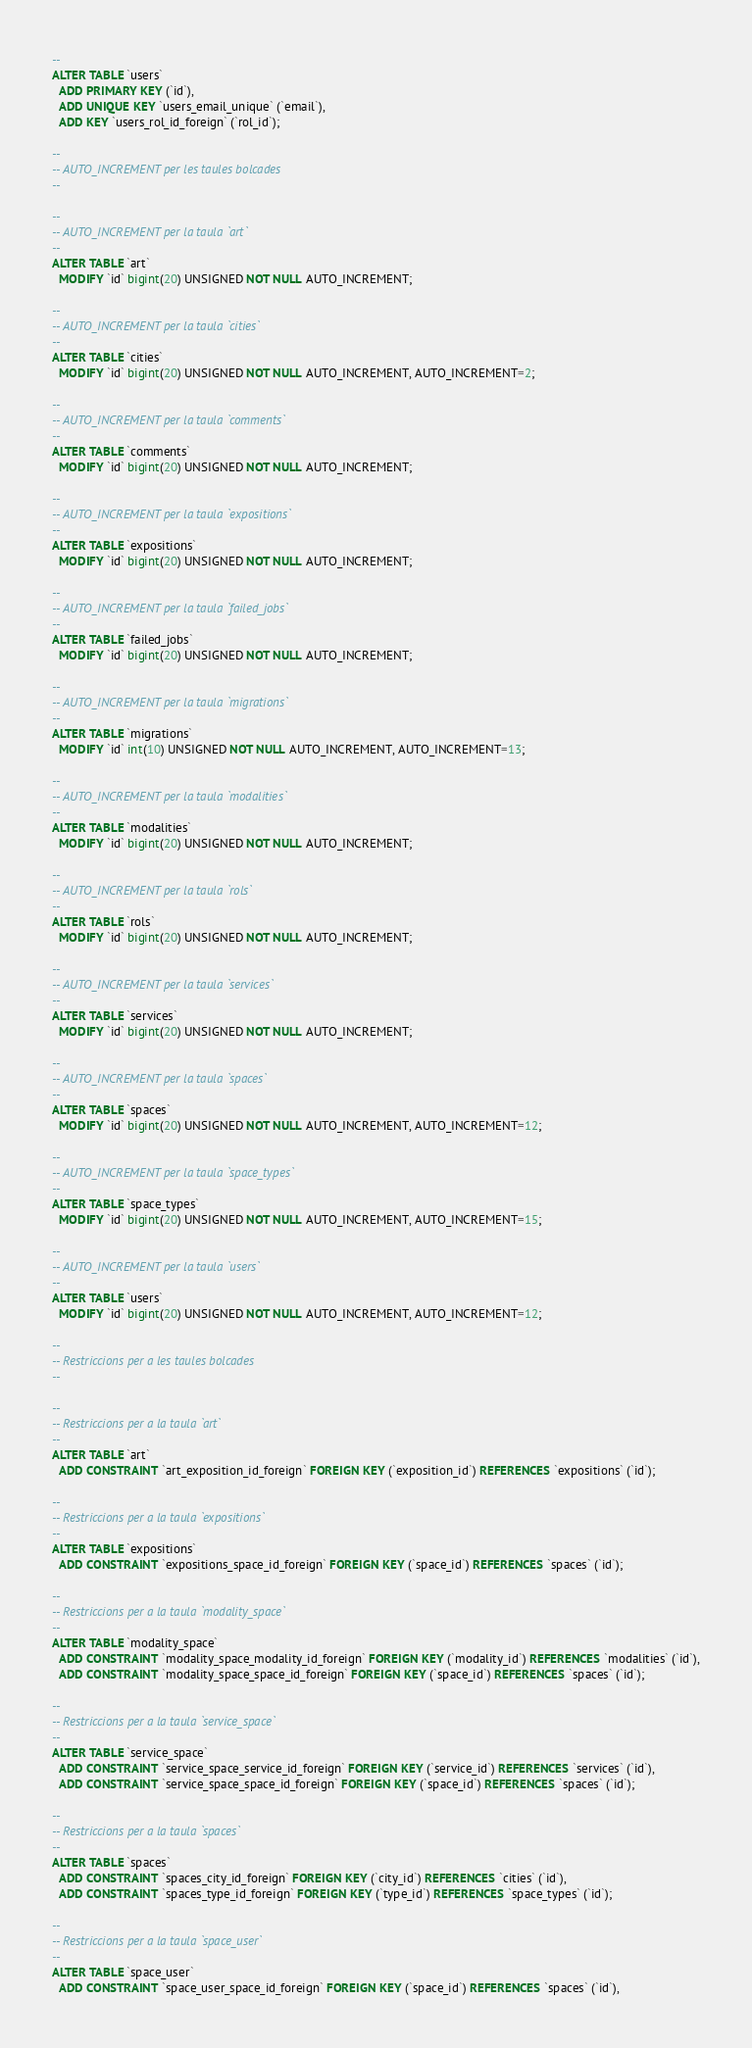Convert code to text. <code><loc_0><loc_0><loc_500><loc_500><_SQL_>--
ALTER TABLE `users`
  ADD PRIMARY KEY (`id`),
  ADD UNIQUE KEY `users_email_unique` (`email`),
  ADD KEY `users_rol_id_foreign` (`rol_id`);

--
-- AUTO_INCREMENT per les taules bolcades
--

--
-- AUTO_INCREMENT per la taula `art`
--
ALTER TABLE `art`
  MODIFY `id` bigint(20) UNSIGNED NOT NULL AUTO_INCREMENT;

--
-- AUTO_INCREMENT per la taula `cities`
--
ALTER TABLE `cities`
  MODIFY `id` bigint(20) UNSIGNED NOT NULL AUTO_INCREMENT, AUTO_INCREMENT=2;

--
-- AUTO_INCREMENT per la taula `comments`
--
ALTER TABLE `comments`
  MODIFY `id` bigint(20) UNSIGNED NOT NULL AUTO_INCREMENT;

--
-- AUTO_INCREMENT per la taula `expositions`
--
ALTER TABLE `expositions`
  MODIFY `id` bigint(20) UNSIGNED NOT NULL AUTO_INCREMENT;

--
-- AUTO_INCREMENT per la taula `failed_jobs`
--
ALTER TABLE `failed_jobs`
  MODIFY `id` bigint(20) UNSIGNED NOT NULL AUTO_INCREMENT;

--
-- AUTO_INCREMENT per la taula `migrations`
--
ALTER TABLE `migrations`
  MODIFY `id` int(10) UNSIGNED NOT NULL AUTO_INCREMENT, AUTO_INCREMENT=13;

--
-- AUTO_INCREMENT per la taula `modalities`
--
ALTER TABLE `modalities`
  MODIFY `id` bigint(20) UNSIGNED NOT NULL AUTO_INCREMENT;

--
-- AUTO_INCREMENT per la taula `rols`
--
ALTER TABLE `rols`
  MODIFY `id` bigint(20) UNSIGNED NOT NULL AUTO_INCREMENT;

--
-- AUTO_INCREMENT per la taula `services`
--
ALTER TABLE `services`
  MODIFY `id` bigint(20) UNSIGNED NOT NULL AUTO_INCREMENT;

--
-- AUTO_INCREMENT per la taula `spaces`
--
ALTER TABLE `spaces`
  MODIFY `id` bigint(20) UNSIGNED NOT NULL AUTO_INCREMENT, AUTO_INCREMENT=12;

--
-- AUTO_INCREMENT per la taula `space_types`
--
ALTER TABLE `space_types`
  MODIFY `id` bigint(20) UNSIGNED NOT NULL AUTO_INCREMENT, AUTO_INCREMENT=15;

--
-- AUTO_INCREMENT per la taula `users`
--
ALTER TABLE `users`
  MODIFY `id` bigint(20) UNSIGNED NOT NULL AUTO_INCREMENT, AUTO_INCREMENT=12;

--
-- Restriccions per a les taules bolcades
--

--
-- Restriccions per a la taula `art`
--
ALTER TABLE `art`
  ADD CONSTRAINT `art_exposition_id_foreign` FOREIGN KEY (`exposition_id`) REFERENCES `expositions` (`id`);

--
-- Restriccions per a la taula `expositions`
--
ALTER TABLE `expositions`
  ADD CONSTRAINT `expositions_space_id_foreign` FOREIGN KEY (`space_id`) REFERENCES `spaces` (`id`);

--
-- Restriccions per a la taula `modality_space`
--
ALTER TABLE `modality_space`
  ADD CONSTRAINT `modality_space_modality_id_foreign` FOREIGN KEY (`modality_id`) REFERENCES `modalities` (`id`),
  ADD CONSTRAINT `modality_space_space_id_foreign` FOREIGN KEY (`space_id`) REFERENCES `spaces` (`id`);

--
-- Restriccions per a la taula `service_space`
--
ALTER TABLE `service_space`
  ADD CONSTRAINT `service_space_service_id_foreign` FOREIGN KEY (`service_id`) REFERENCES `services` (`id`),
  ADD CONSTRAINT `service_space_space_id_foreign` FOREIGN KEY (`space_id`) REFERENCES `spaces` (`id`);

--
-- Restriccions per a la taula `spaces`
--
ALTER TABLE `spaces`
  ADD CONSTRAINT `spaces_city_id_foreign` FOREIGN KEY (`city_id`) REFERENCES `cities` (`id`),
  ADD CONSTRAINT `spaces_type_id_foreign` FOREIGN KEY (`type_id`) REFERENCES `space_types` (`id`);

--
-- Restriccions per a la taula `space_user`
--
ALTER TABLE `space_user`
  ADD CONSTRAINT `space_user_space_id_foreign` FOREIGN KEY (`space_id`) REFERENCES `spaces` (`id`),</code> 